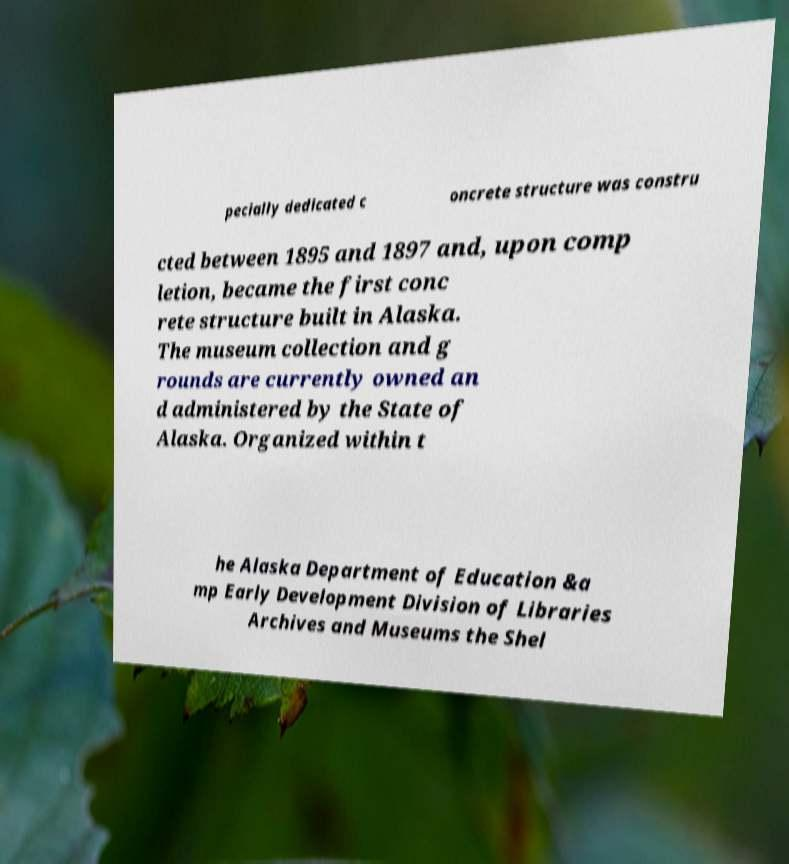Please read and relay the text visible in this image. What does it say? pecially dedicated c oncrete structure was constru cted between 1895 and 1897 and, upon comp letion, became the first conc rete structure built in Alaska. The museum collection and g rounds are currently owned an d administered by the State of Alaska. Organized within t he Alaska Department of Education &a mp Early Development Division of Libraries Archives and Museums the Shel 